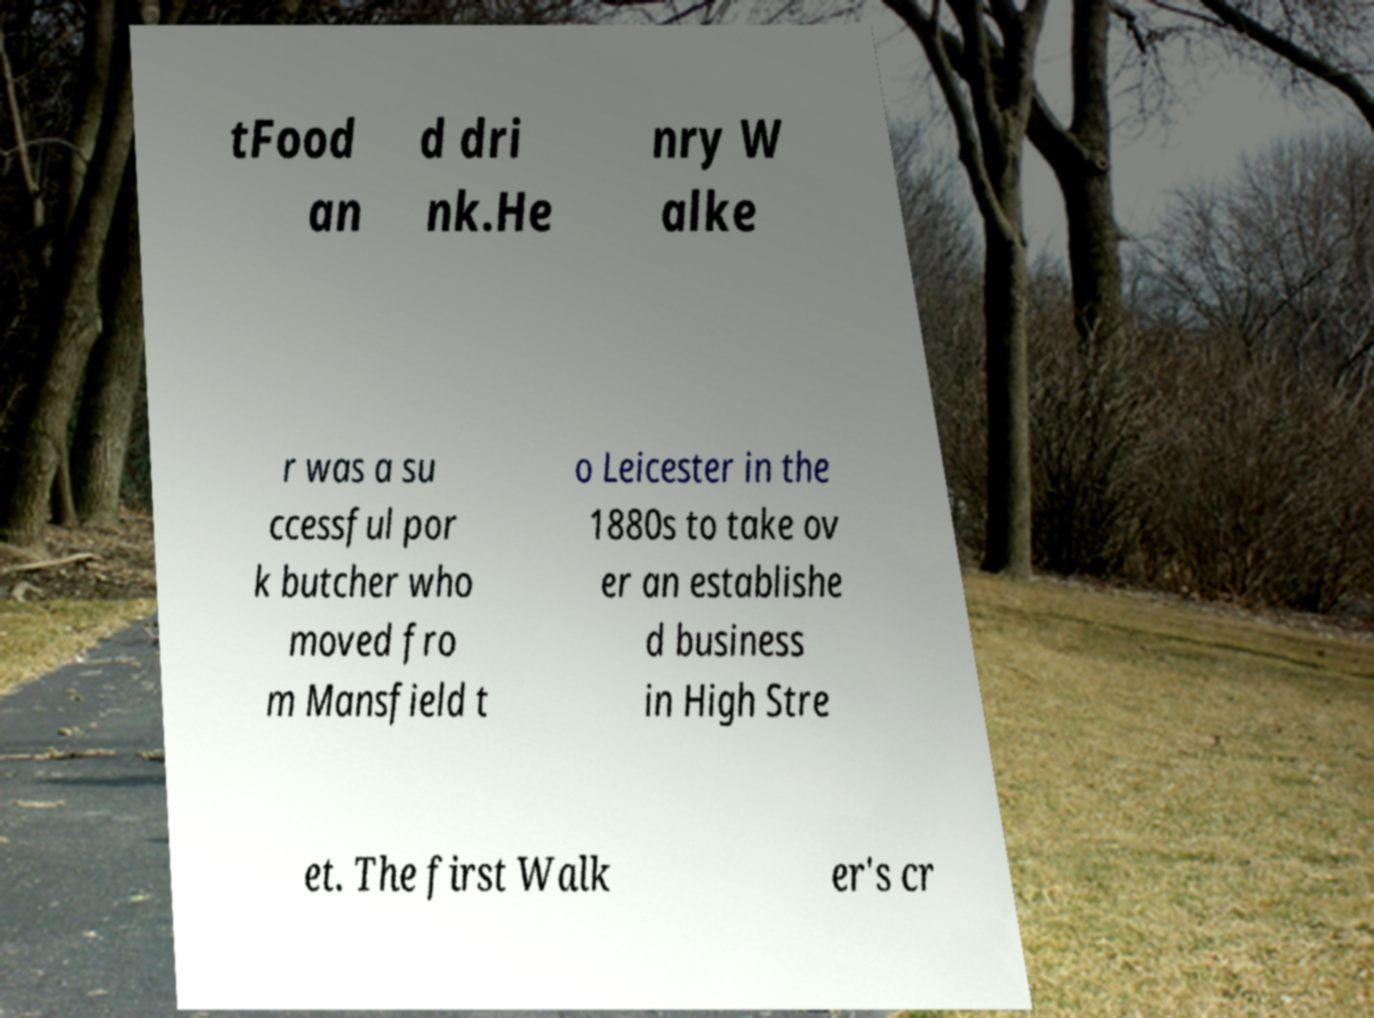Could you extract and type out the text from this image? tFood an d dri nk.He nry W alke r was a su ccessful por k butcher who moved fro m Mansfield t o Leicester in the 1880s to take ov er an establishe d business in High Stre et. The first Walk er's cr 